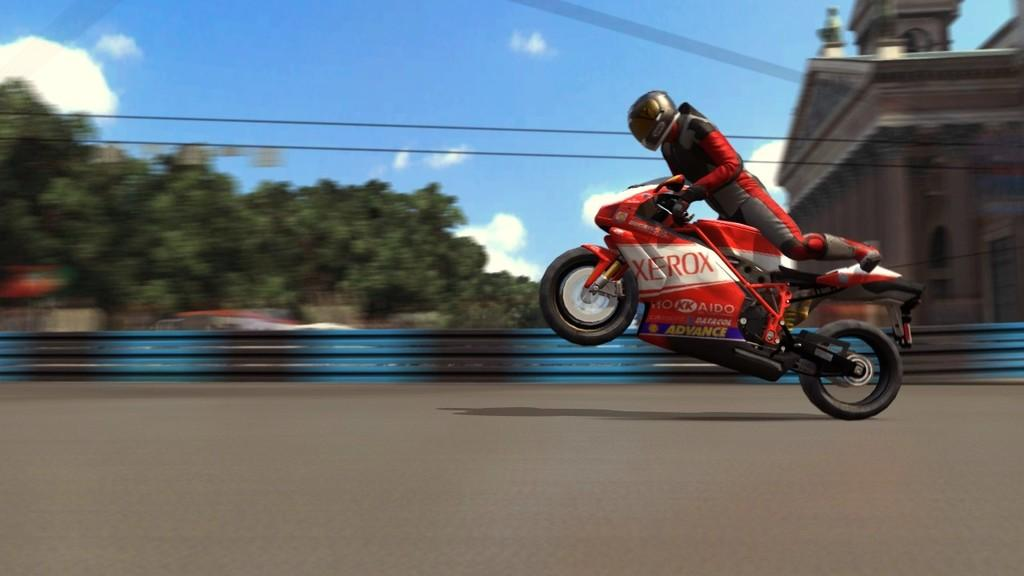What is the main subject of the image? There is a person in the image. What is the person wearing? The person is wearing a helmet. What is the person doing in the image? The person is riding a motorbike. Where is the motorbike located? The motorbike is on the road. What can be seen in the background of the image? There are trees, at least one building, and the sky visible in the background of the image. What is the condition of the sky in the image? The sky is visible with clouds in the background of the image. How many sisters does the person on the motorbike have in the image? There is no information about the person's sisters in the image. What type of pet can be seen accompanying the person on the motorbike? There is no pet visible in the image. 